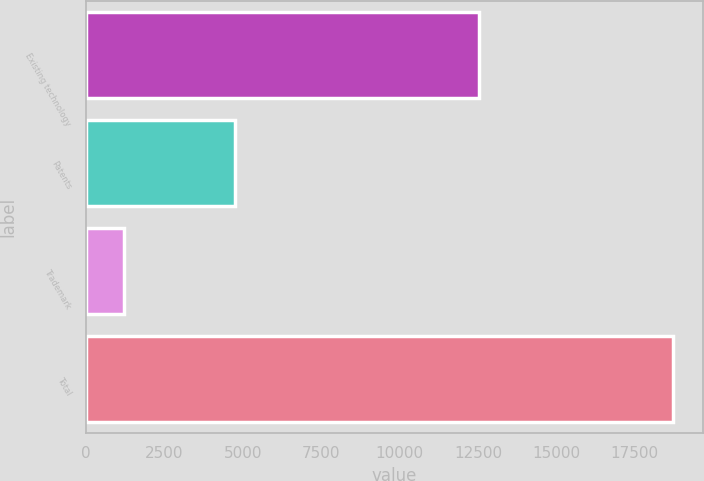Convert chart to OTSL. <chart><loc_0><loc_0><loc_500><loc_500><bar_chart><fcel>Existing technology<fcel>Patents<fcel>Trademark<fcel>Total<nl><fcel>12537<fcel>4761<fcel>1225<fcel>18723<nl></chart> 